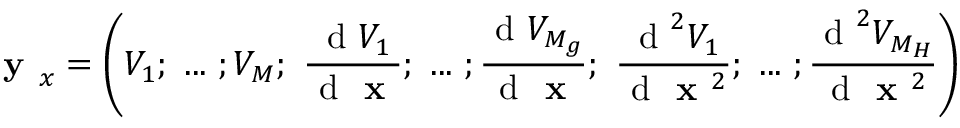<formula> <loc_0><loc_0><loc_500><loc_500>y _ { x } = \left ( V _ { 1 } ; \dots ; V _ { M } ; \frac { d V _ { 1 } } { d x } ; \dots ; \frac { d V _ { M _ { g } } } { d x } ; \frac { d ^ { 2 } V _ { 1 } } { d x ^ { 2 } } ; \dots ; \frac { d ^ { 2 } V _ { M _ { H } } } { d x ^ { 2 } } \right )</formula> 